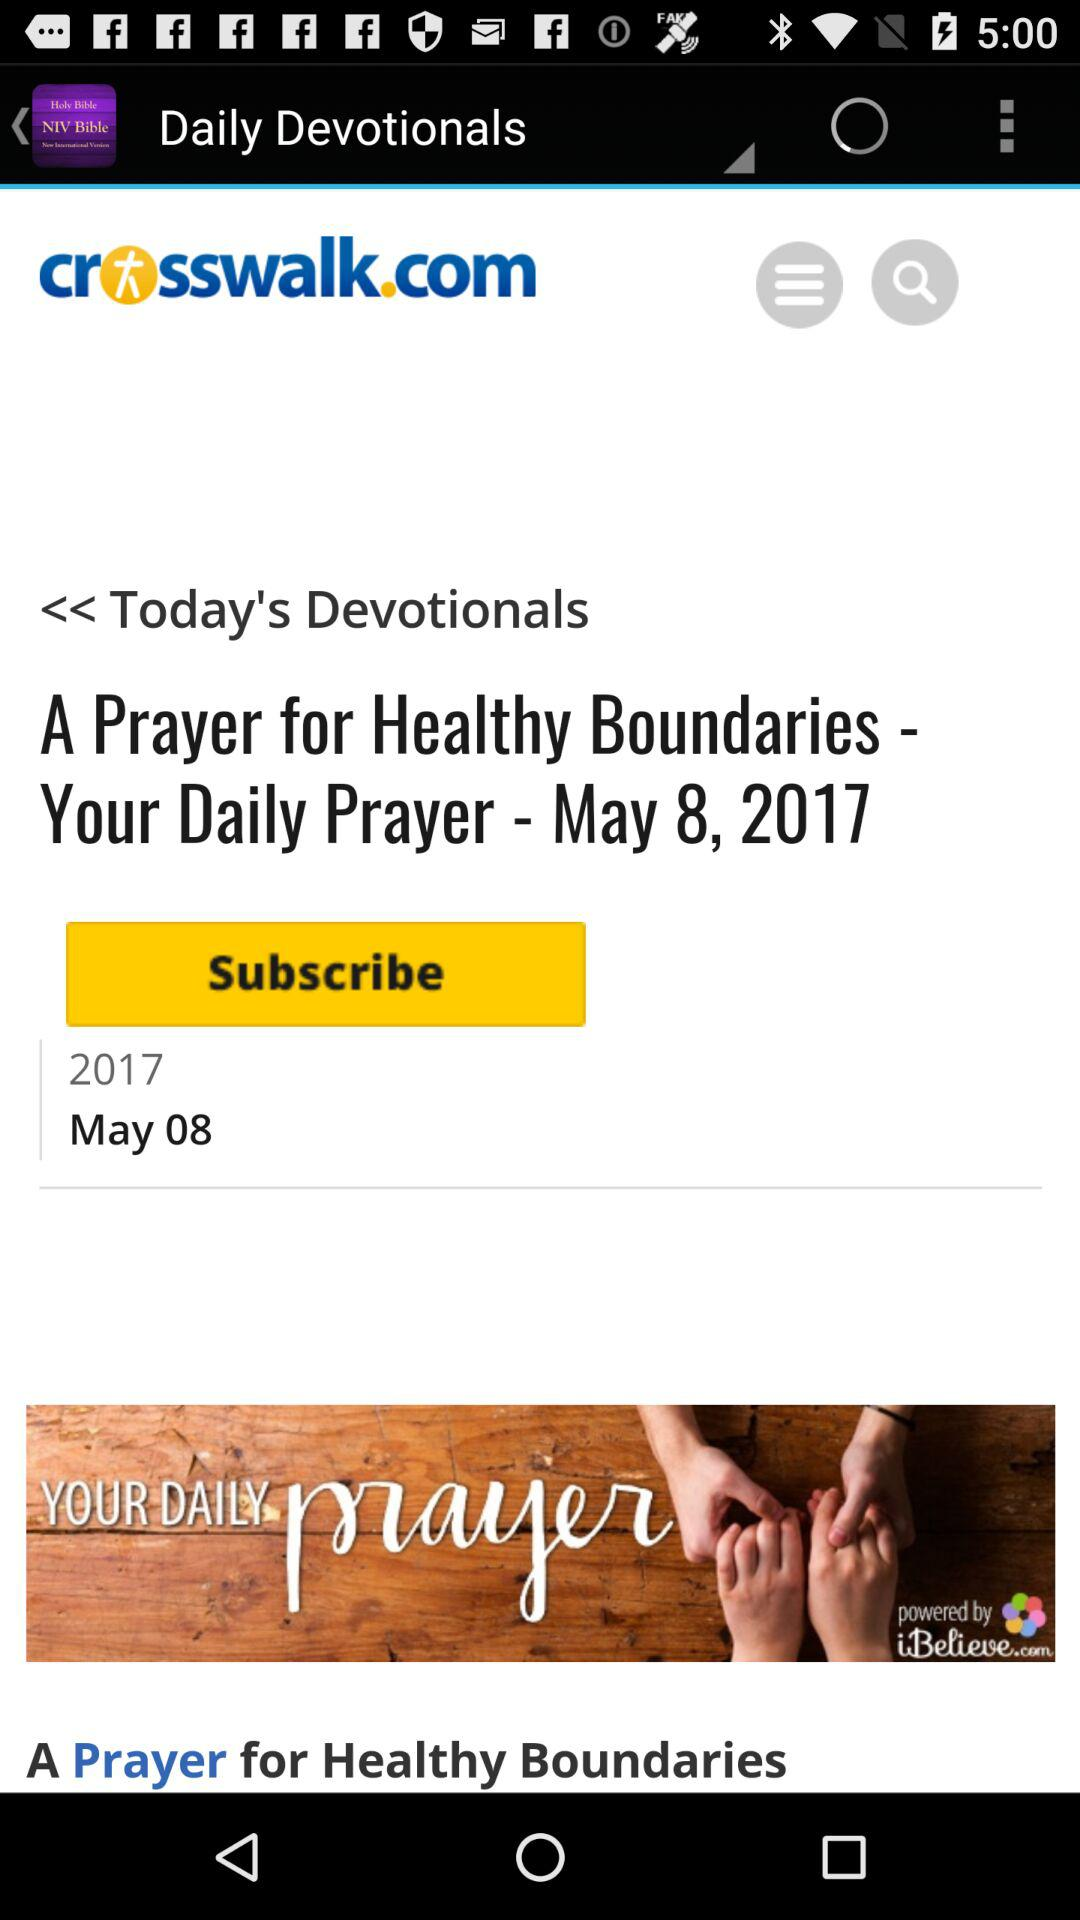What is the website name? The website's name is "Daily Devotionals". 